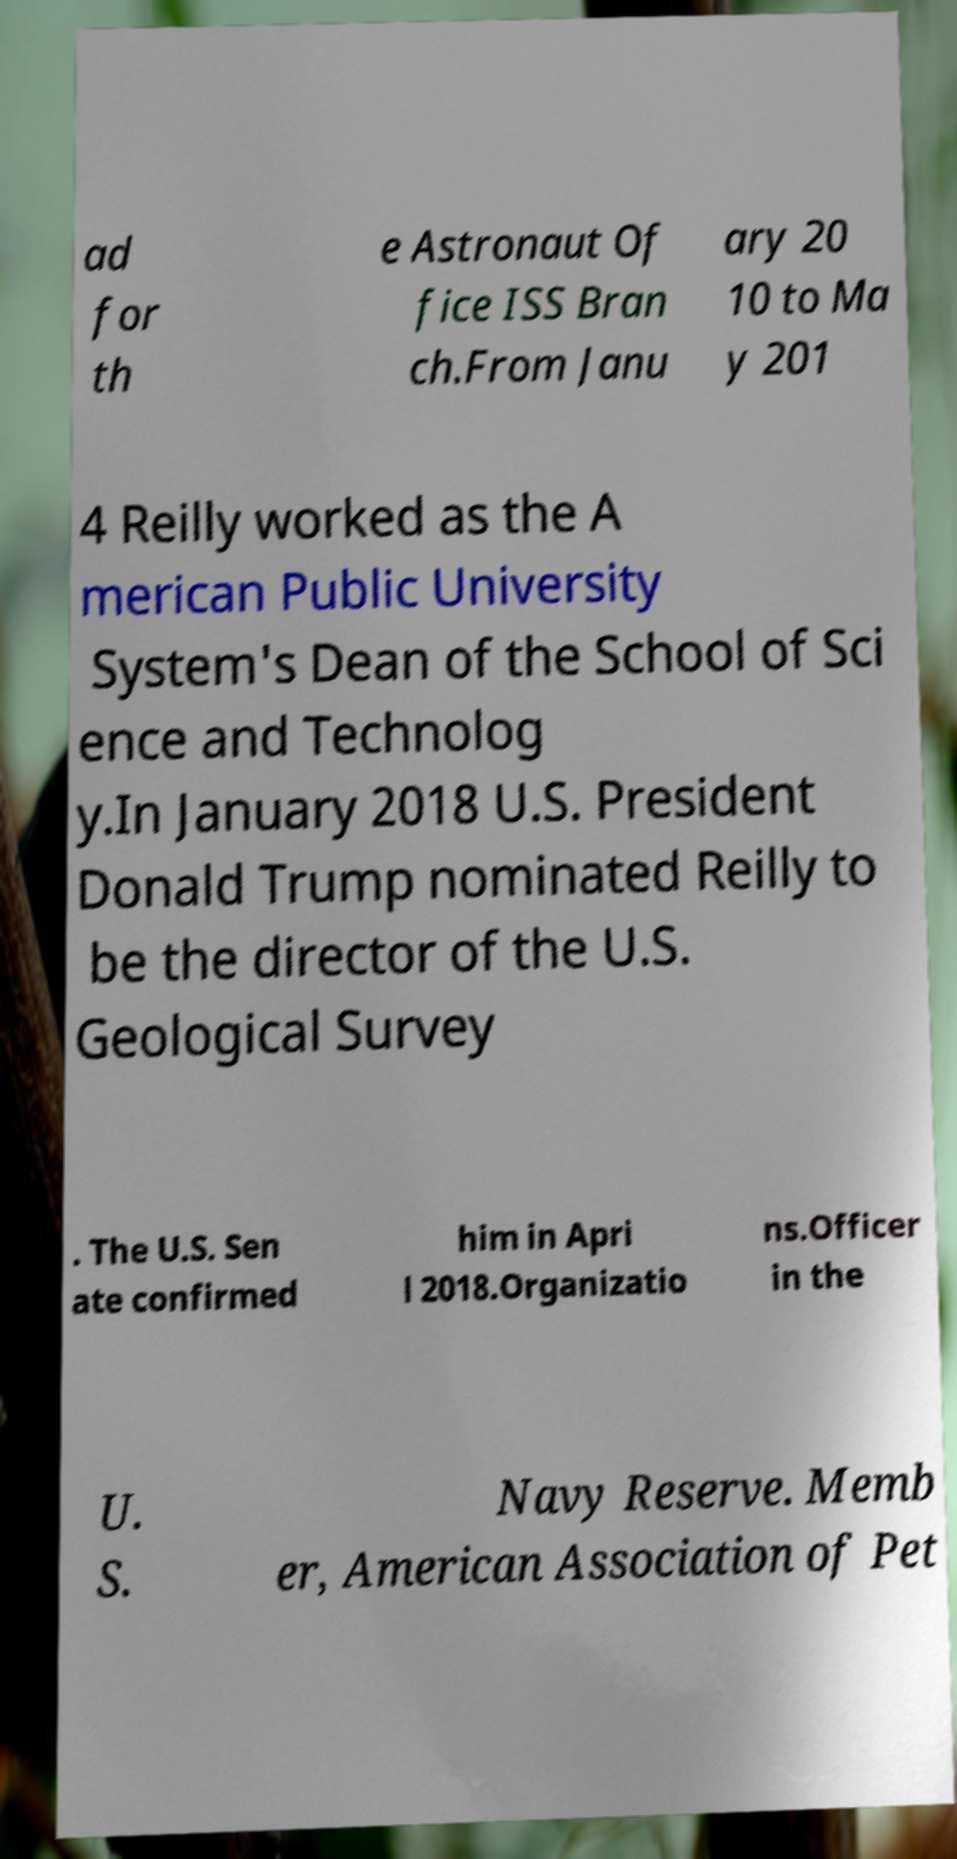Please identify and transcribe the text found in this image. ad for th e Astronaut Of fice ISS Bran ch.From Janu ary 20 10 to Ma y 201 4 Reilly worked as the A merican Public University System's Dean of the School of Sci ence and Technolog y.In January 2018 U.S. President Donald Trump nominated Reilly to be the director of the U.S. Geological Survey . The U.S. Sen ate confirmed him in Apri l 2018.Organizatio ns.Officer in the U. S. Navy Reserve. Memb er, American Association of Pet 